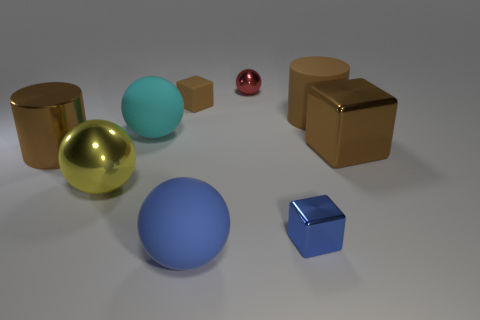How many cyan balls are the same size as the yellow metal sphere? There is one cyan ball that appears to be the same size as the yellow metal sphere in this image. 